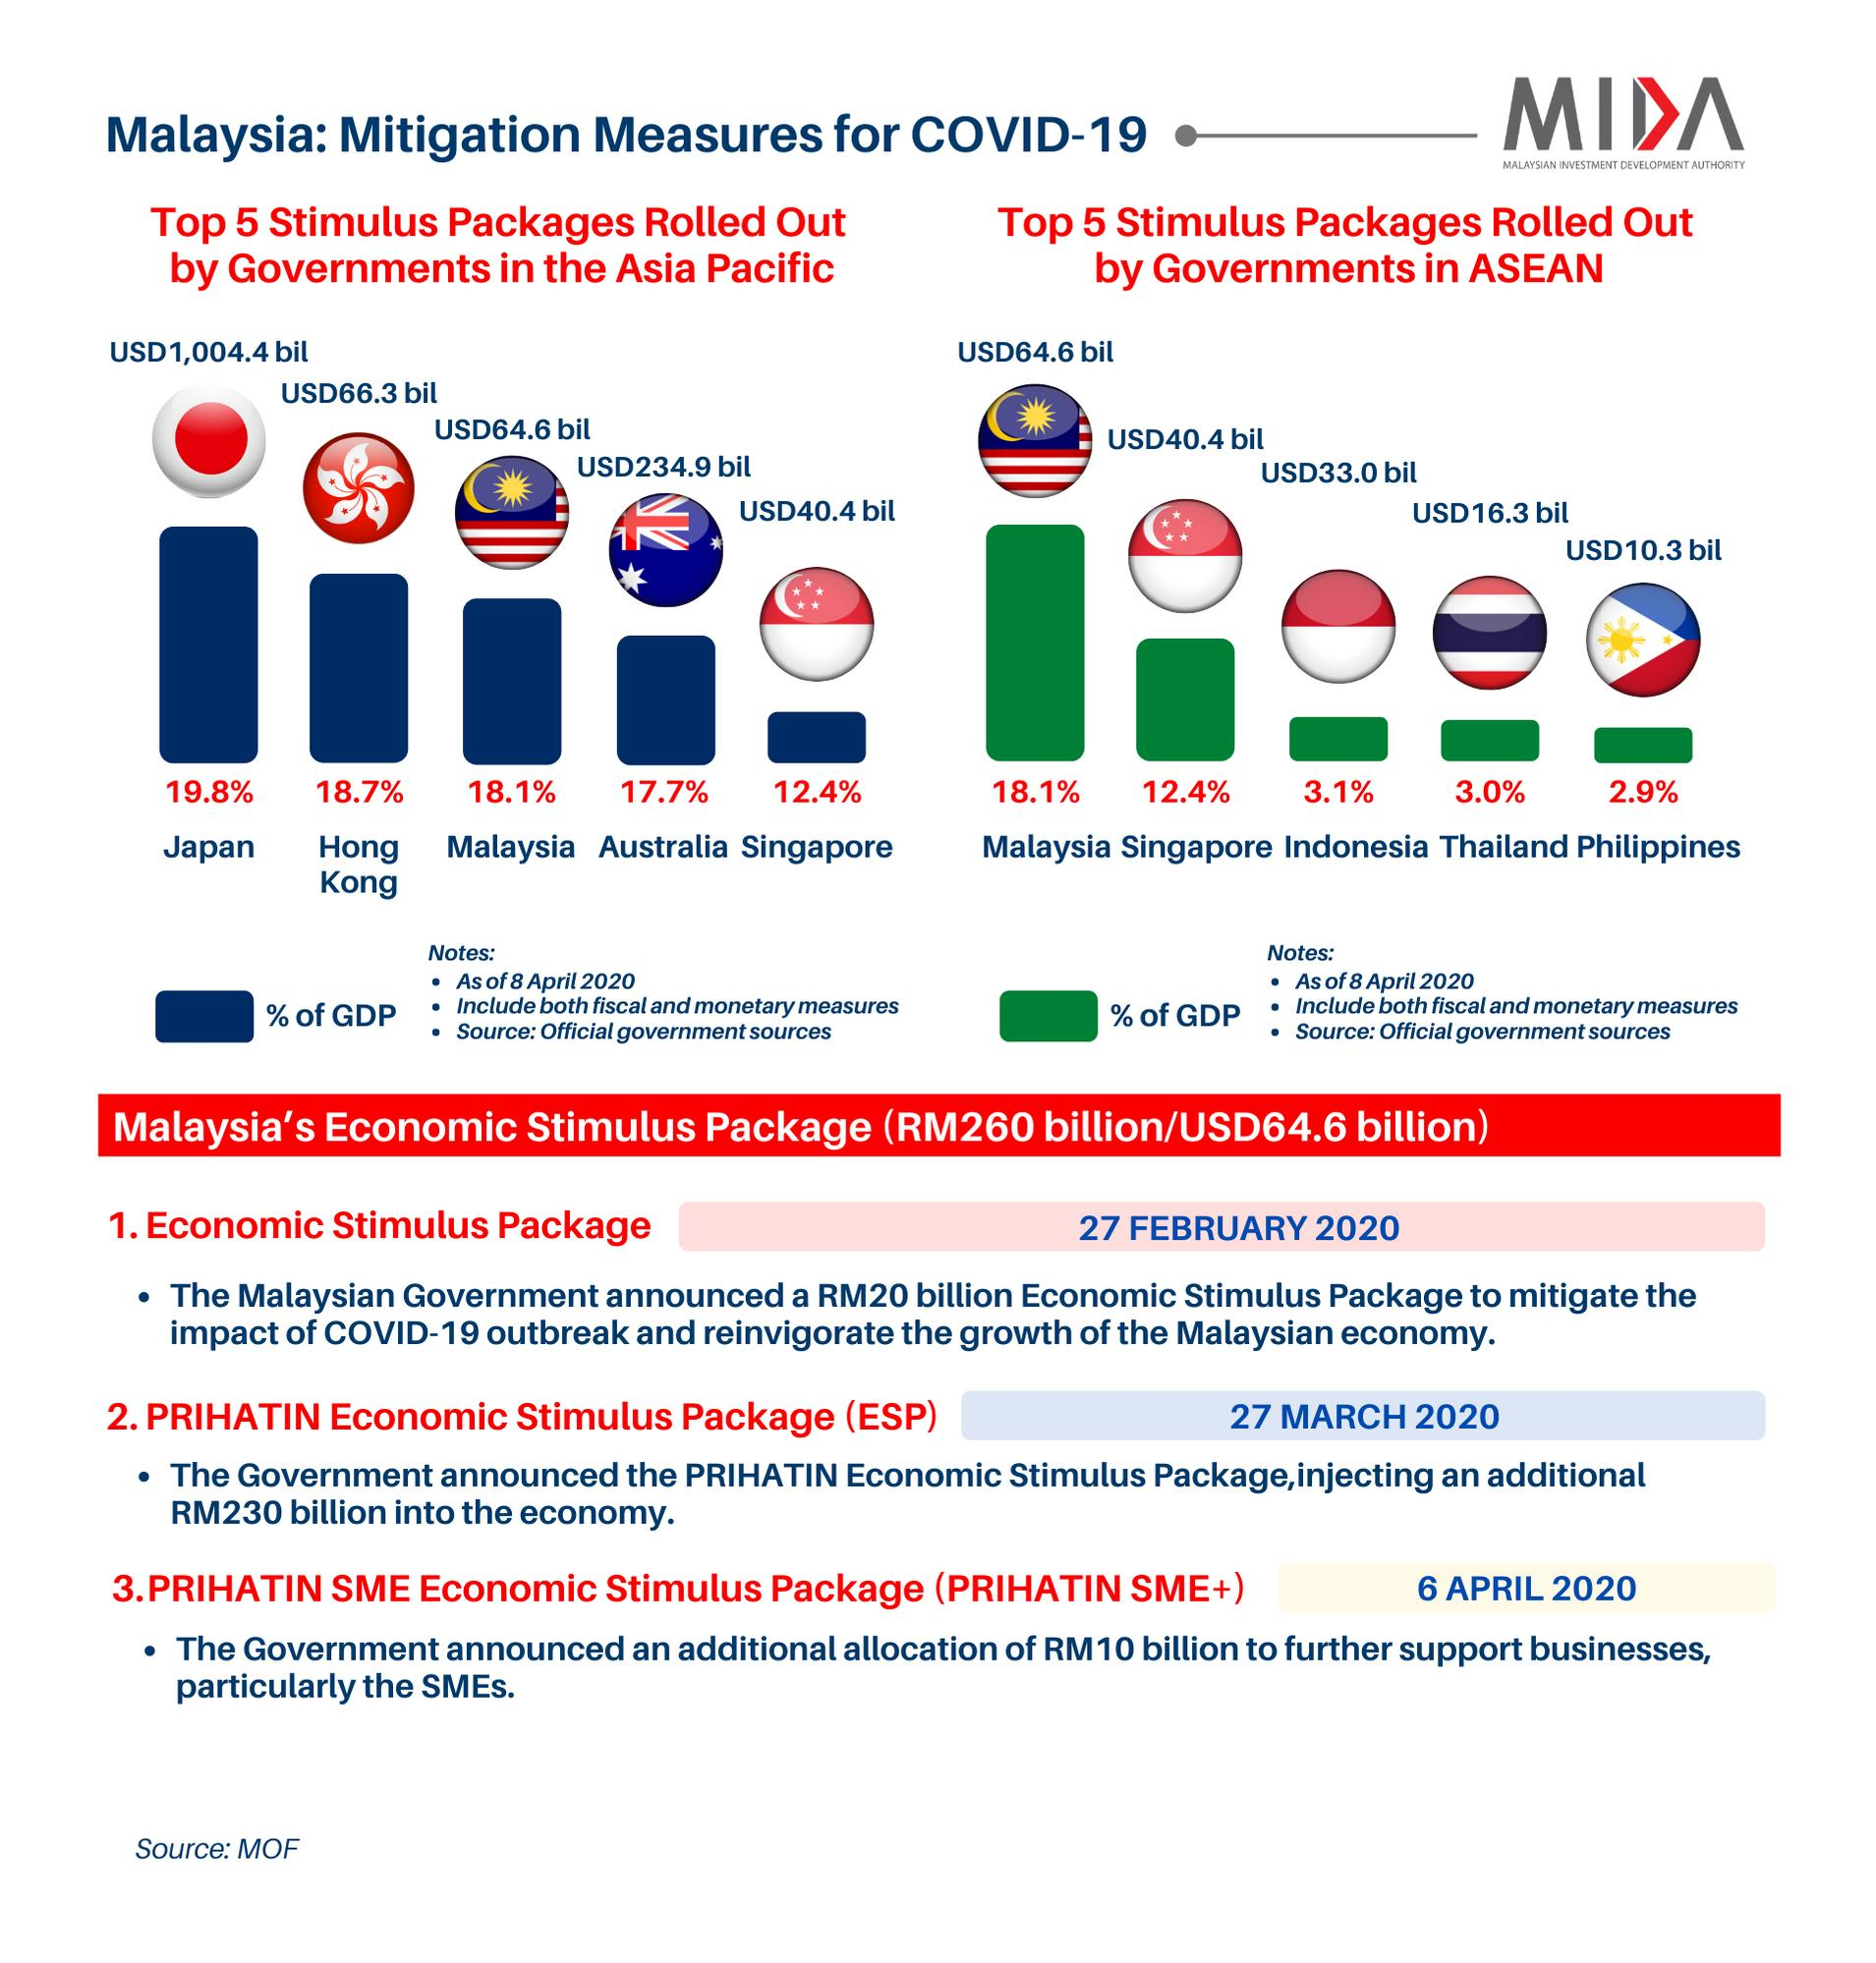Outline some significant characteristics in this image. Thailand has the second lowest stimulus package in terms of GDP among ASEAN governments. Australia has the second lowest stimulus package in terms of GDP among Asian governments. Singapore has the second highest stimulus package in terms of GDP among ASEAN governments. Hong Kong has the second highest stimulus package in terms of GDP among Asian governments. Malaysia has the third highest stimulus package in terms of GDP among Asian governments. 